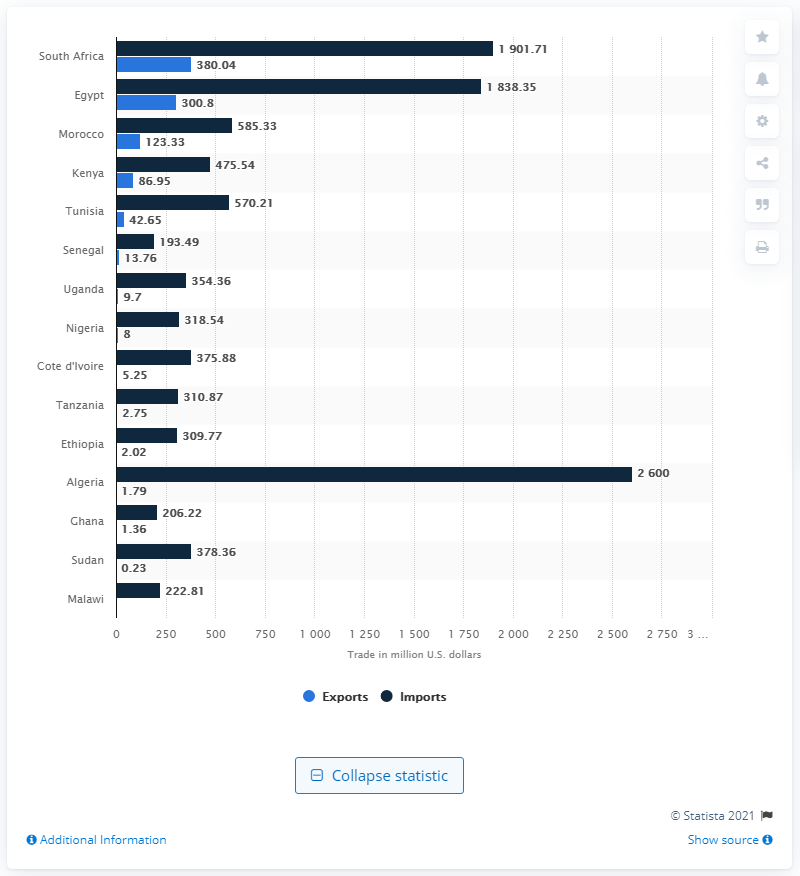Specify some key components in this picture. According to data from 2014, Algeria was the top African country in terms of imports of pharmaceuticals. In 2014, South Africa exported 380.04 million U.S. dollars to other countries. According to data from 2014, Algeria was the top African country in terms of pharmaceutical imports. 